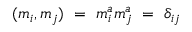Convert formula to latex. <formula><loc_0><loc_0><loc_500><loc_500>( m _ { i } , m _ { j } ) \ = \ m _ { i } ^ { a } m _ { j } ^ { a } \ = \ \delta _ { i j }</formula> 